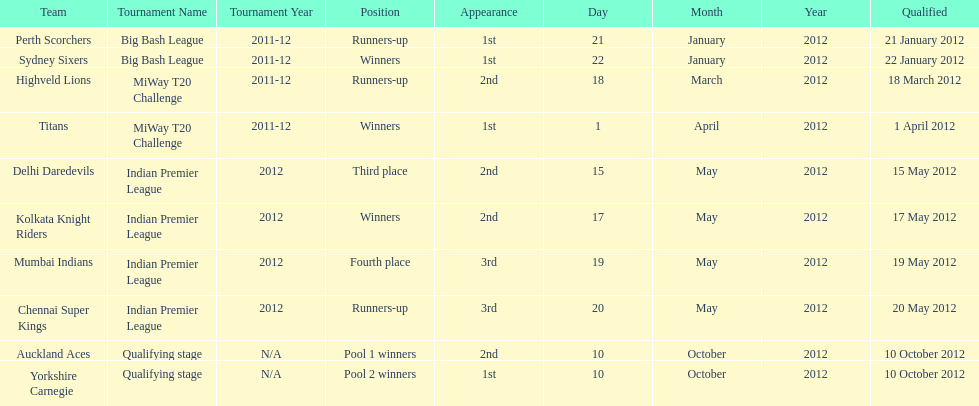Did the titans or the daredevils winners? Titans. 